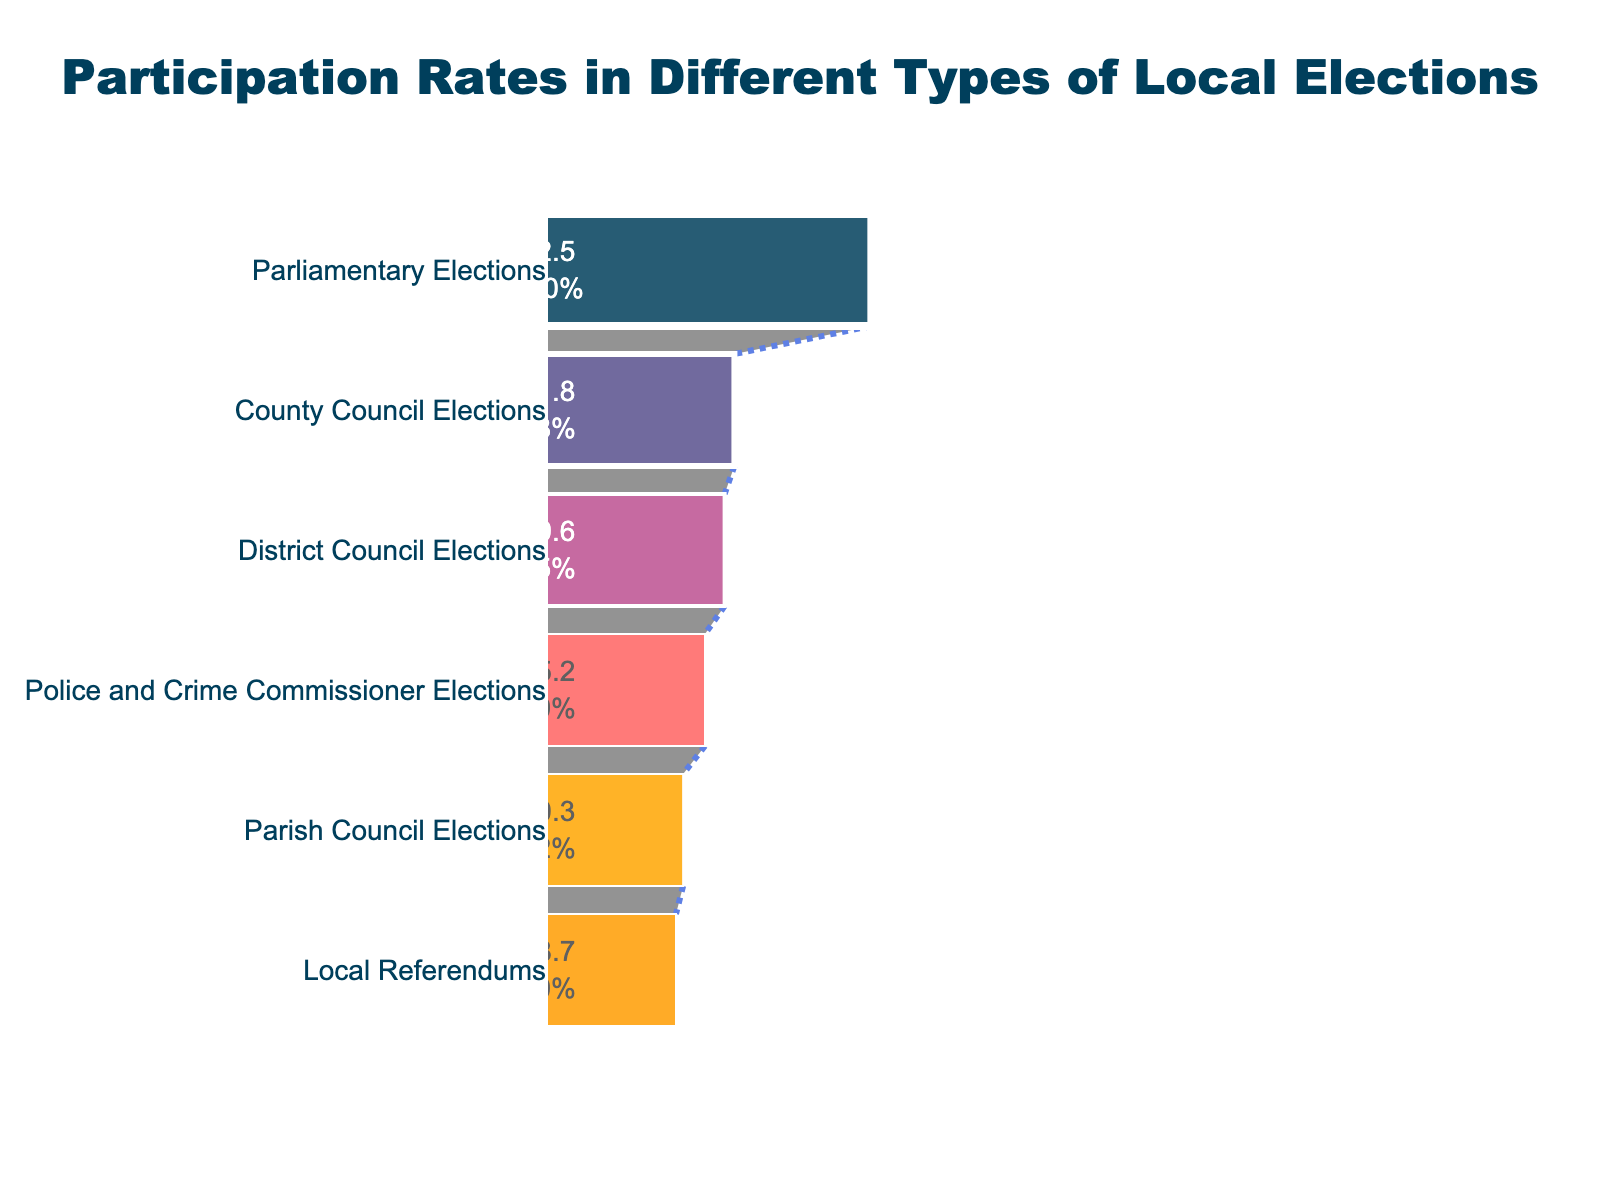What's the highest participation rate in the funnel chart? The highest participation rate can be found by identifying the stage with the largest value on the chart.
Answer: 72.5% What's the difference in participation rates between the highest and lowest stages? Subtract the lowest participation rate from the highest participation rate. 72.5% - 28.7% = 43.8%
Answer: 43.8% Which stage has the lowest participation rate? Look for the stage with the smallest value on the chart.
Answer: Local Referendums Arrange the stages in descending order of participation rates. Starting from the highest to the lowest participation rates: Parliamentary Elections > County Council Elections > District Council Elections > Parish Council Elections > Police and Crime Commissioner Elections > Local Referendums.
Answer: Parliamentary Elections, County Council Elections, District Council Elections, Parish Council Elections, Police and Crime Commissioner Elections, Local Referendums What is the participation rate at the Police and Crime Commissioner Elections stage? Refer to the chart where the participation rate for Police and Crime Commissioner Elections is displayed.
Answer: 35.2% What is the average participation rate of all the stages? Sum all participation rates and divide by the number of stages: (72.5% + 35.2% + 41.8% + 39.6% + 30.3% + 28.7%) / 6 = 41.35%
Answer: 41.35% Do more people participate in District Council Elections compared to Parish Council Elections? Compare the participation rates of District Council Elections and Parish Council Elections: 39.6% > 30.3%.
Answer: Yes By how much does participation in County Council Elections exceed that of Parish Council Elections? Subtract Parish Council Elections participation rate from County Council Elections: 41.8% - 30.3% = 11.5%.
Answer: 11.5% How does participation in Local Referendums compare to Police and Crime Commissioner Elections? Compare the participation rates: 28.7% < 35.2%.
Answer: Local Referendums has a lower rate Which stage has slightly lower participation than County Council Elections? Identify the stage just below County Council Elections participation rate of 41.8%: District Council Elections with 39.6%.
Answer: District Council Elections 